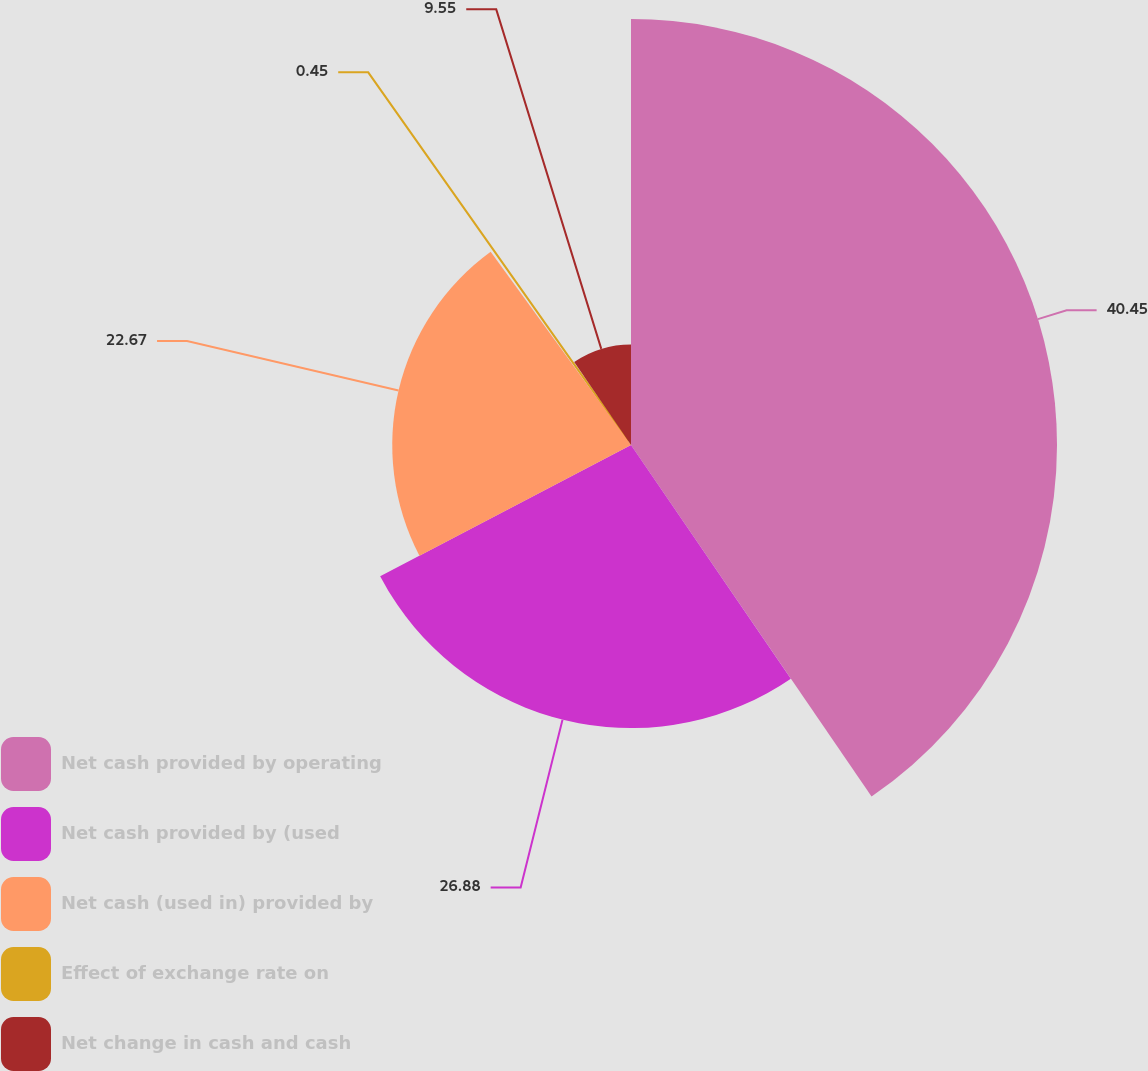Convert chart. <chart><loc_0><loc_0><loc_500><loc_500><pie_chart><fcel>Net cash provided by operating<fcel>Net cash provided by (used<fcel>Net cash (used in) provided by<fcel>Effect of exchange rate on<fcel>Net change in cash and cash<nl><fcel>40.45%<fcel>26.88%<fcel>22.67%<fcel>0.45%<fcel>9.55%<nl></chart> 